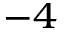Convert formula to latex. <formula><loc_0><loc_0><loc_500><loc_500>^ { - 4 }</formula> 